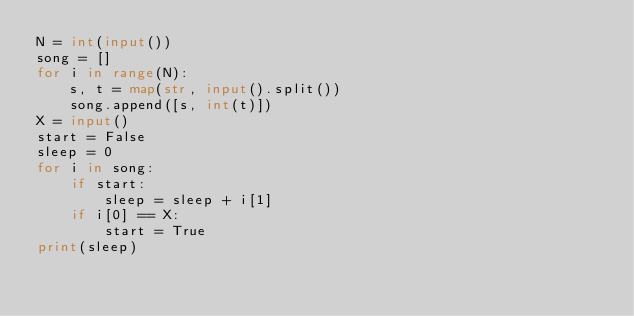<code> <loc_0><loc_0><loc_500><loc_500><_Python_>N = int(input())
song = []
for i in range(N):
    s, t = map(str, input().split())
    song.append([s, int(t)])
X = input()
start = False
sleep = 0
for i in song:
    if start:
        sleep = sleep + i[1]
    if i[0] == X:
        start = True
print(sleep)
</code> 